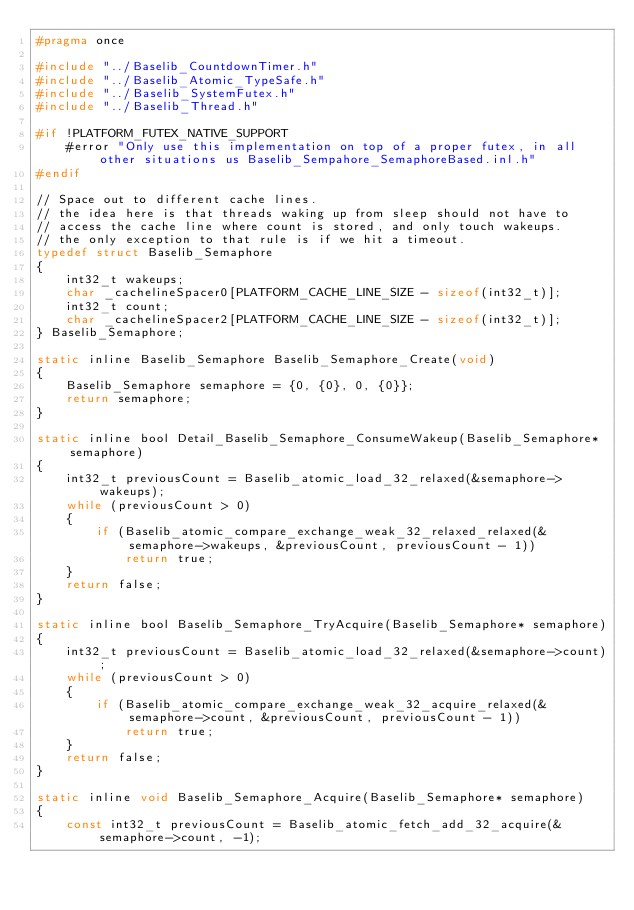Convert code to text. <code><loc_0><loc_0><loc_500><loc_500><_C_>#pragma once

#include "../Baselib_CountdownTimer.h"
#include "../Baselib_Atomic_TypeSafe.h"
#include "../Baselib_SystemFutex.h"
#include "../Baselib_Thread.h"

#if !PLATFORM_FUTEX_NATIVE_SUPPORT
    #error "Only use this implementation on top of a proper futex, in all other situations us Baselib_Sempahore_SemaphoreBased.inl.h"
#endif

// Space out to different cache lines.
// the idea here is that threads waking up from sleep should not have to
// access the cache line where count is stored, and only touch wakeups.
// the only exception to that rule is if we hit a timeout.
typedef struct Baselib_Semaphore
{
    int32_t wakeups;
    char _cachelineSpacer0[PLATFORM_CACHE_LINE_SIZE - sizeof(int32_t)];
    int32_t count;
    char _cachelineSpacer2[PLATFORM_CACHE_LINE_SIZE - sizeof(int32_t)];
} Baselib_Semaphore;

static inline Baselib_Semaphore Baselib_Semaphore_Create(void)
{
    Baselib_Semaphore semaphore = {0, {0}, 0, {0}};
    return semaphore;
}

static inline bool Detail_Baselib_Semaphore_ConsumeWakeup(Baselib_Semaphore* semaphore)
{
    int32_t previousCount = Baselib_atomic_load_32_relaxed(&semaphore->wakeups);
    while (previousCount > 0)
    {
        if (Baselib_atomic_compare_exchange_weak_32_relaxed_relaxed(&semaphore->wakeups, &previousCount, previousCount - 1))
            return true;
    }
    return false;
}

static inline bool Baselib_Semaphore_TryAcquire(Baselib_Semaphore* semaphore)
{
    int32_t previousCount = Baselib_atomic_load_32_relaxed(&semaphore->count);
    while (previousCount > 0)
    {
        if (Baselib_atomic_compare_exchange_weak_32_acquire_relaxed(&semaphore->count, &previousCount, previousCount - 1))
            return true;
    }
    return false;
}

static inline void Baselib_Semaphore_Acquire(Baselib_Semaphore* semaphore)
{
    const int32_t previousCount = Baselib_atomic_fetch_add_32_acquire(&semaphore->count, -1);</code> 